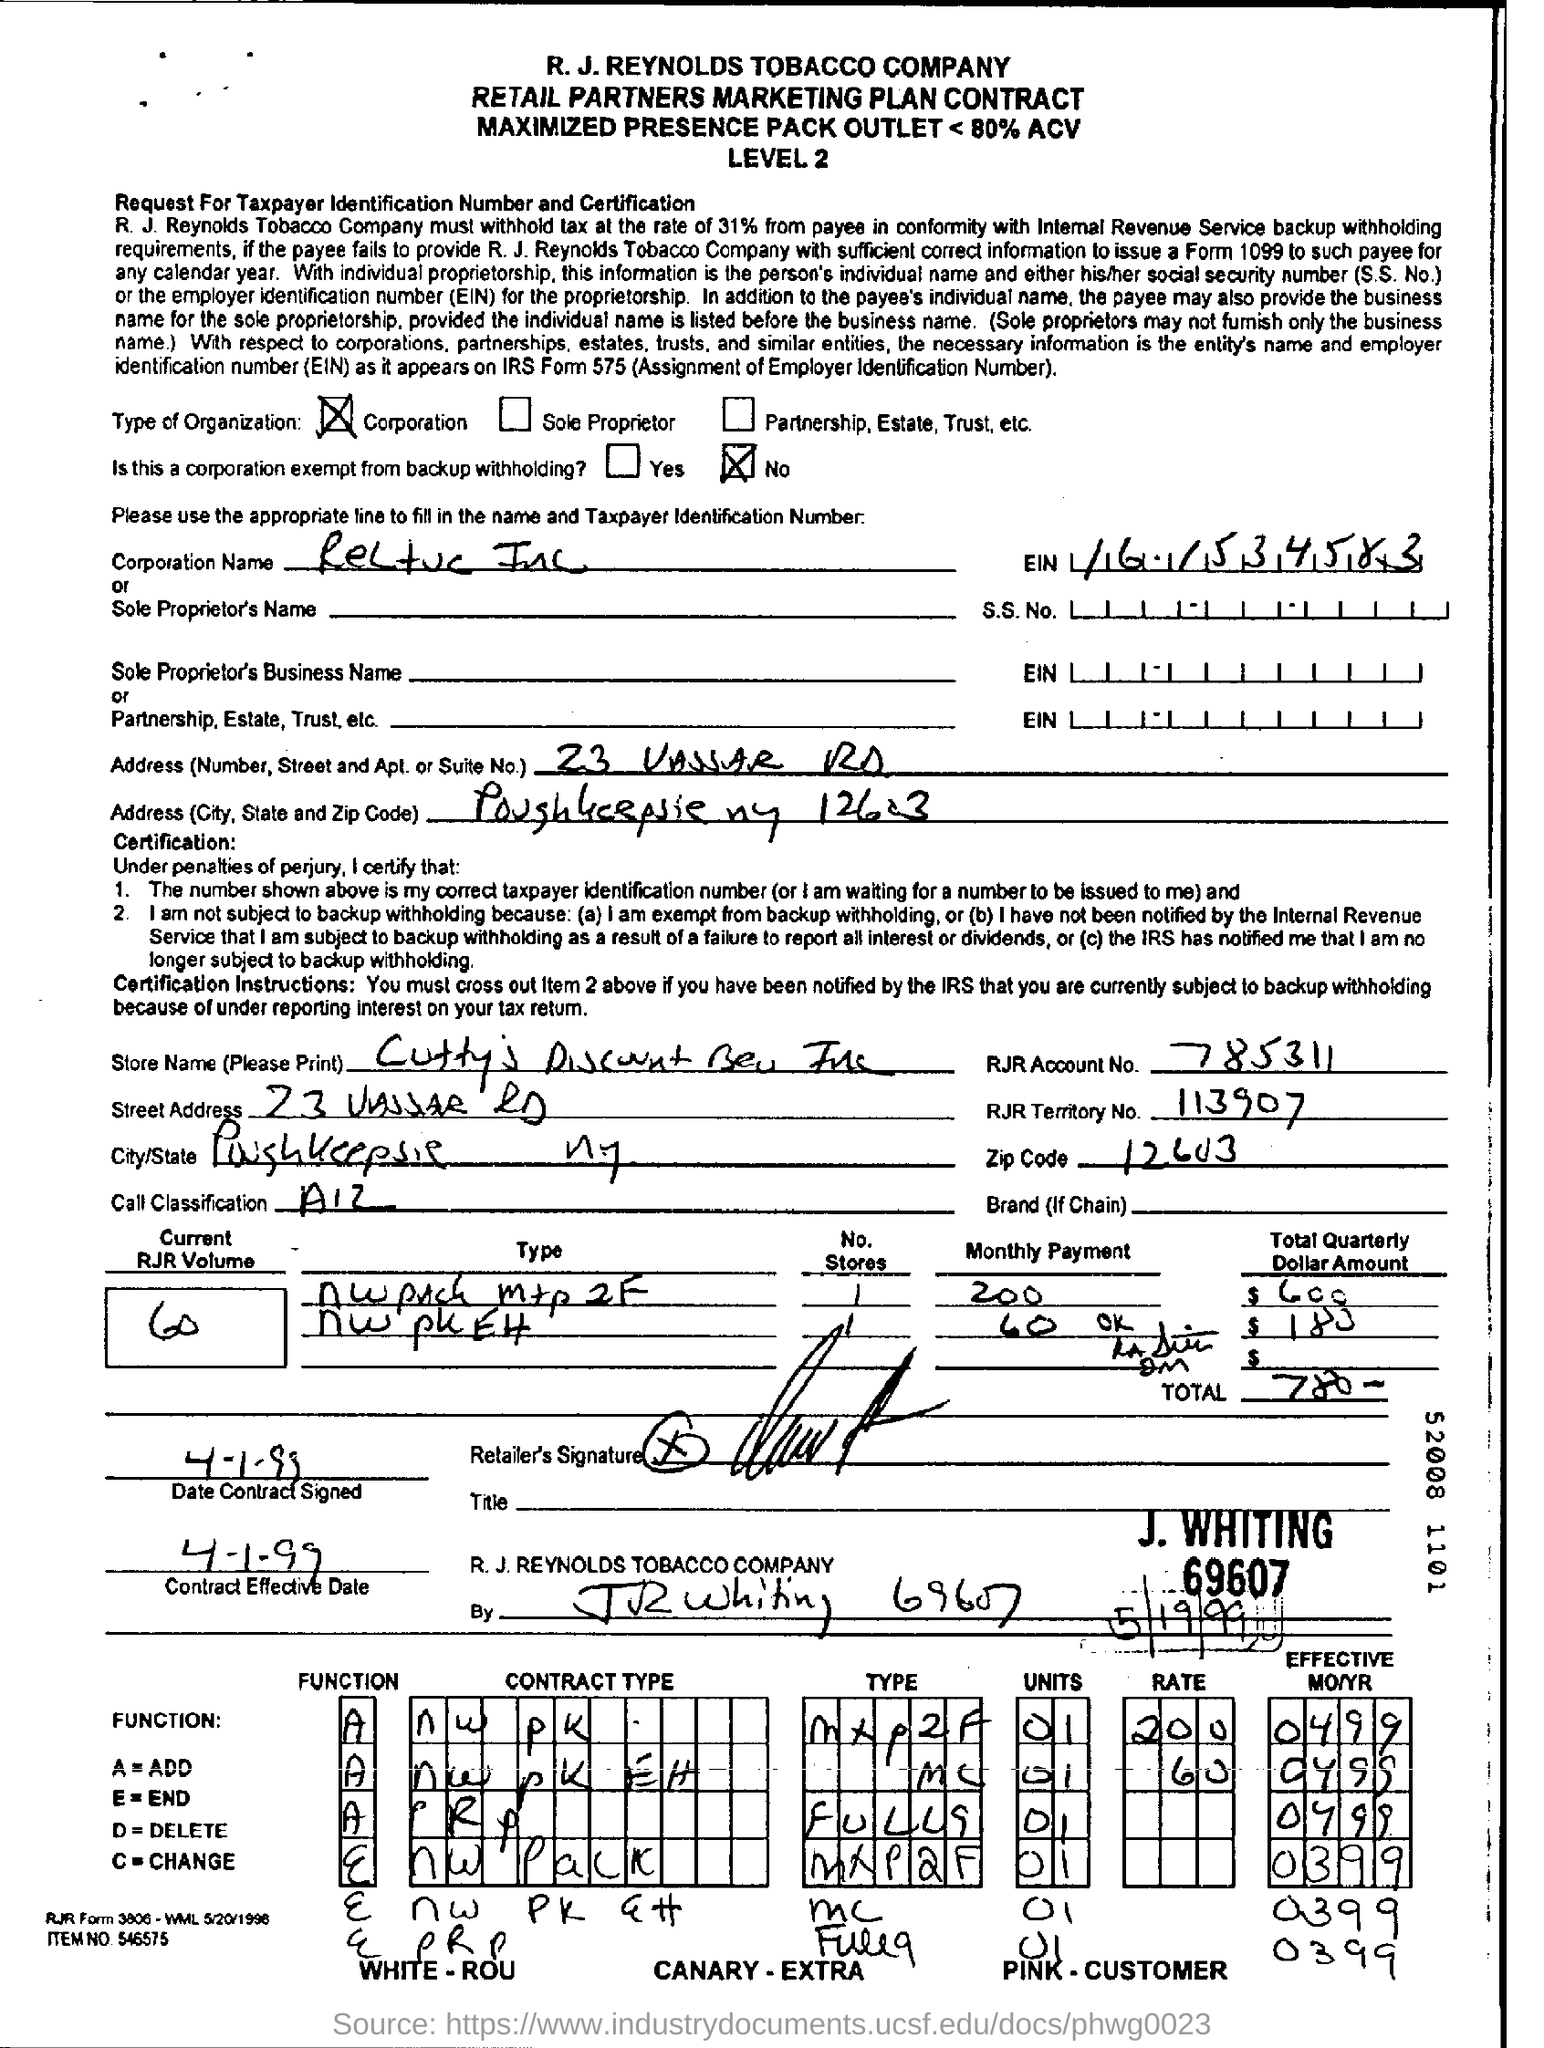What is the RJR account no given in the form?
Keep it short and to the point. 785311. What is the RJR Account number?
Make the answer very short. 785311. 